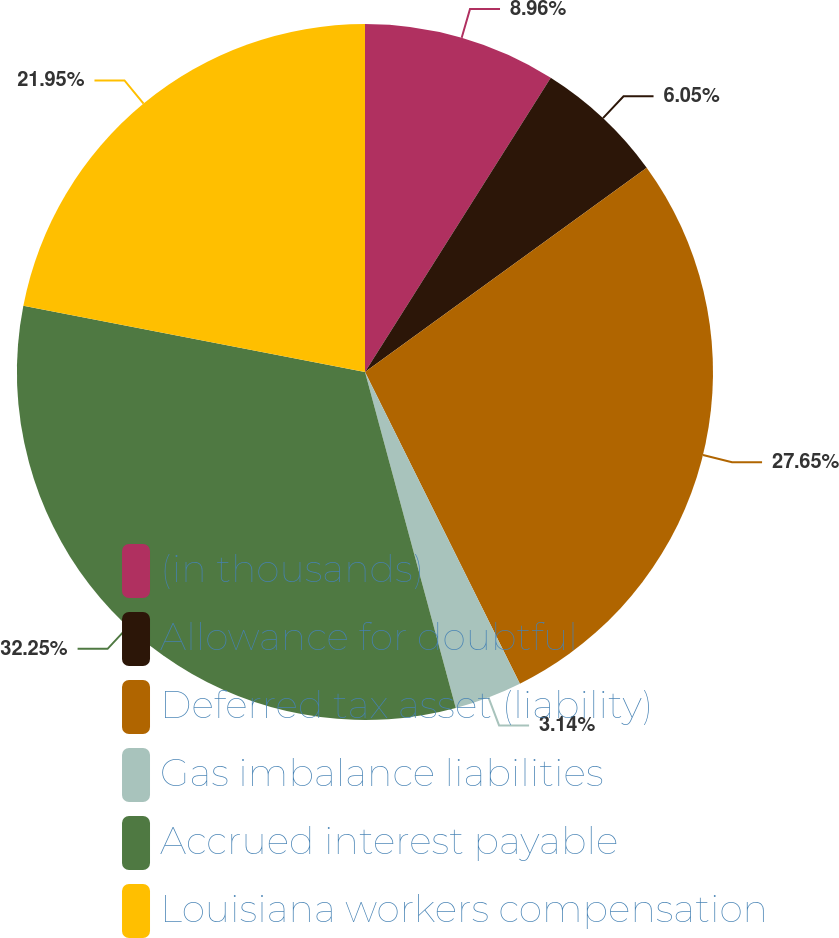Convert chart. <chart><loc_0><loc_0><loc_500><loc_500><pie_chart><fcel>(in thousands)<fcel>Allowance for doubtful<fcel>Deferred tax asset (liability)<fcel>Gas imbalance liabilities<fcel>Accrued interest payable<fcel>Louisiana workers compensation<nl><fcel>8.96%<fcel>6.05%<fcel>27.64%<fcel>3.14%<fcel>32.24%<fcel>21.95%<nl></chart> 